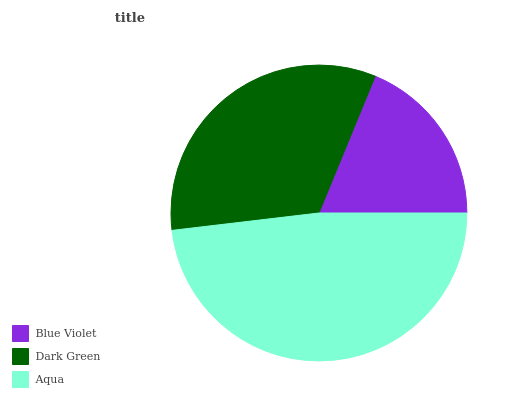Is Blue Violet the minimum?
Answer yes or no. Yes. Is Aqua the maximum?
Answer yes or no. Yes. Is Dark Green the minimum?
Answer yes or no. No. Is Dark Green the maximum?
Answer yes or no. No. Is Dark Green greater than Blue Violet?
Answer yes or no. Yes. Is Blue Violet less than Dark Green?
Answer yes or no. Yes. Is Blue Violet greater than Dark Green?
Answer yes or no. No. Is Dark Green less than Blue Violet?
Answer yes or no. No. Is Dark Green the high median?
Answer yes or no. Yes. Is Dark Green the low median?
Answer yes or no. Yes. Is Blue Violet the high median?
Answer yes or no. No. Is Aqua the low median?
Answer yes or no. No. 